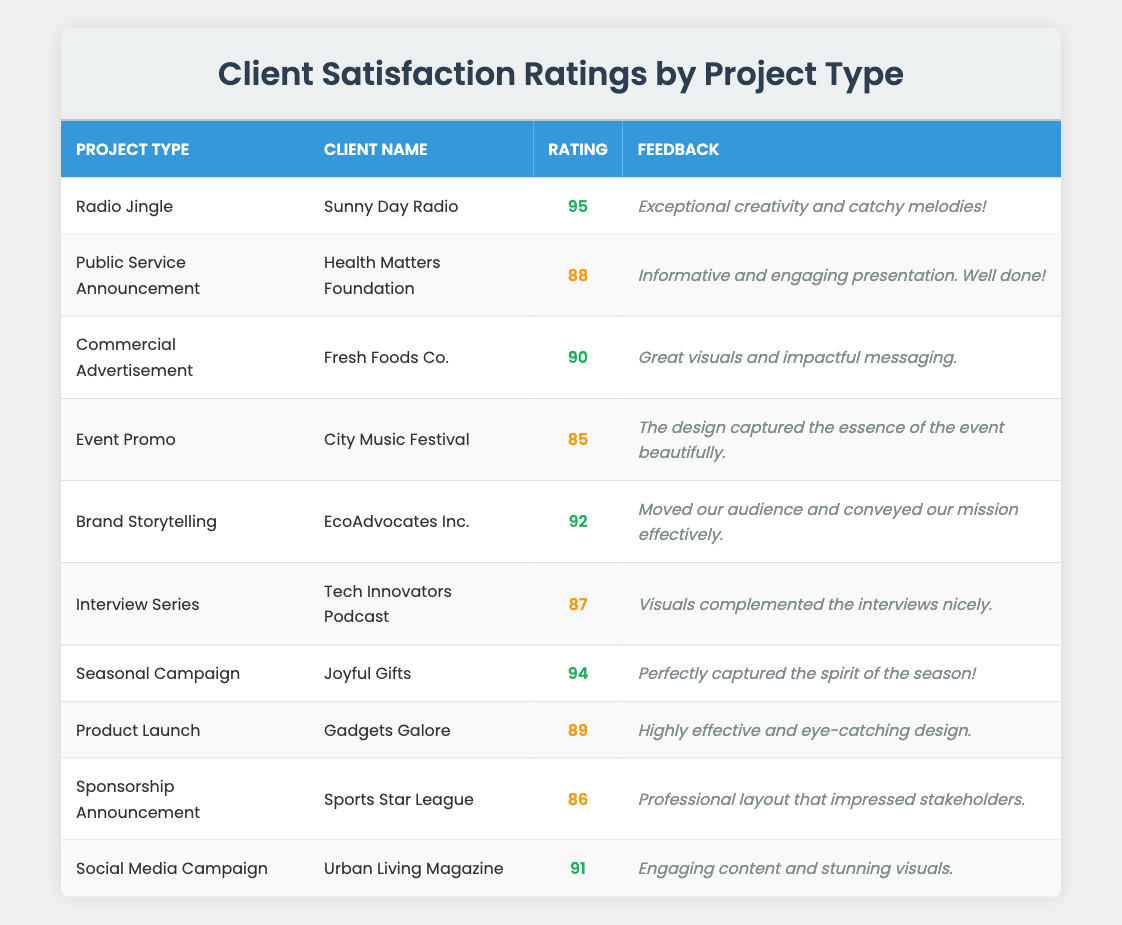What is the highest client satisfaction rating? The table shows the ratings for each project type. By reviewing the ratings, 95 from the "Radio Jingle" project is the highest.
Answer: 95 Which client gave a rating of 88? Looking at the table, the client with a rating of 88 is the "Health Matters Foundation," associated with the "Public Service Announcement."
Answer: Health Matters Foundation What project type received the lowest rating? The ratings can be summarized from the table, where the "Event Promo" project type received the lowest rating of 85.
Answer: Event Promo How many project types have ratings above 90? By scanning through the table, there are four project types with ratings higher than 90: "Radio Jingle," "Commercial Advertisement," "Brand Storytelling," and "Seasonal Campaign."
Answer: 4 Is there a project type with a rating of 86? Checking the table, there is a project type listed with a rating of 86, which is the "Sponsorship Announcement."
Answer: Yes What is the average client satisfaction rating across all projects? To find the average, first sum the ratings: 95 + 88 + 90 + 85 + 92 + 87 + 94 + 89 + 86 + 91 = 916. Then, divide by the number of projects (10): 916 / 10 = 91.6.
Answer: 91.6 Which project type had feedback related to effective audience engagement? The "Social Media Campaign" for "Urban Living Magazine" received feedback about engaging content and stunning visuals, indicating effective audience engagement.
Answer: Social Media Campaign What are the two project types with ratings closest to each other? Comparing the ratings, the "Product Launch" (89) and "Sponsorship Announcement" (86) have the closest ratings, only 3 points apart.
Answer: Product Launch and Sponsorship Announcement How many ratings are less than 90? From the table, the ratings less than 90 are for "Public Service Announcement" (88), "Event Promo" (85), "Interview Series" (87), "Sponsorship Announcement" (86), giving a total of 4 ratings.
Answer: 4 Which feedback mentioned "captured the essence of the event"? The feedback stating "The design captured the essence of the event beautifully." is associated with the "Event Promo" project type for "City Music Festival."
Answer: Event Promo 